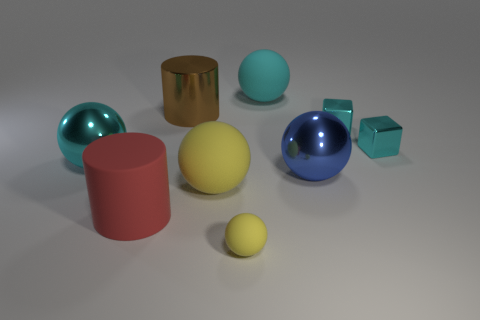Subtract all red cylinders. How many yellow balls are left? 2 Subtract 1 balls. How many balls are left? 4 Subtract all cyan rubber balls. How many balls are left? 4 Add 1 brown metallic cylinders. How many objects exist? 10 Subtract all blue balls. How many balls are left? 4 Subtract all spheres. How many objects are left? 4 Subtract all red balls. Subtract all blue cubes. How many balls are left? 5 Subtract all small metallic blocks. Subtract all large cylinders. How many objects are left? 5 Add 1 large yellow matte spheres. How many large yellow matte spheres are left? 2 Add 7 large brown cylinders. How many large brown cylinders exist? 8 